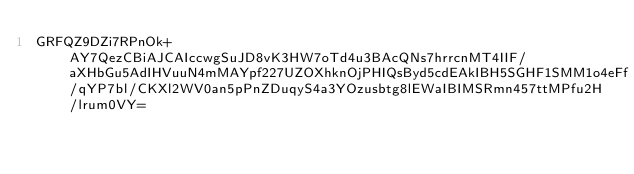<code> <loc_0><loc_0><loc_500><loc_500><_SML_>GRFQZ9DZi7RPnOk+AY7QezCBiAJCAIccwgSuJD8vK3HW7oTd4u3BAcQNs7hrrcnMT4IIF/aXHbGu5AdIHVuuN4mMAYpf227UZOXhknOjPHIQsByd5cdEAkIBH5SGHF1SMM1o4eFf/qYP7bl/CKXl2WV0an5pPnZDuqyS4a3YOzusbtg8lEWaIBIMSRmn457ttMPfu2H/lrum0VY=</code> 